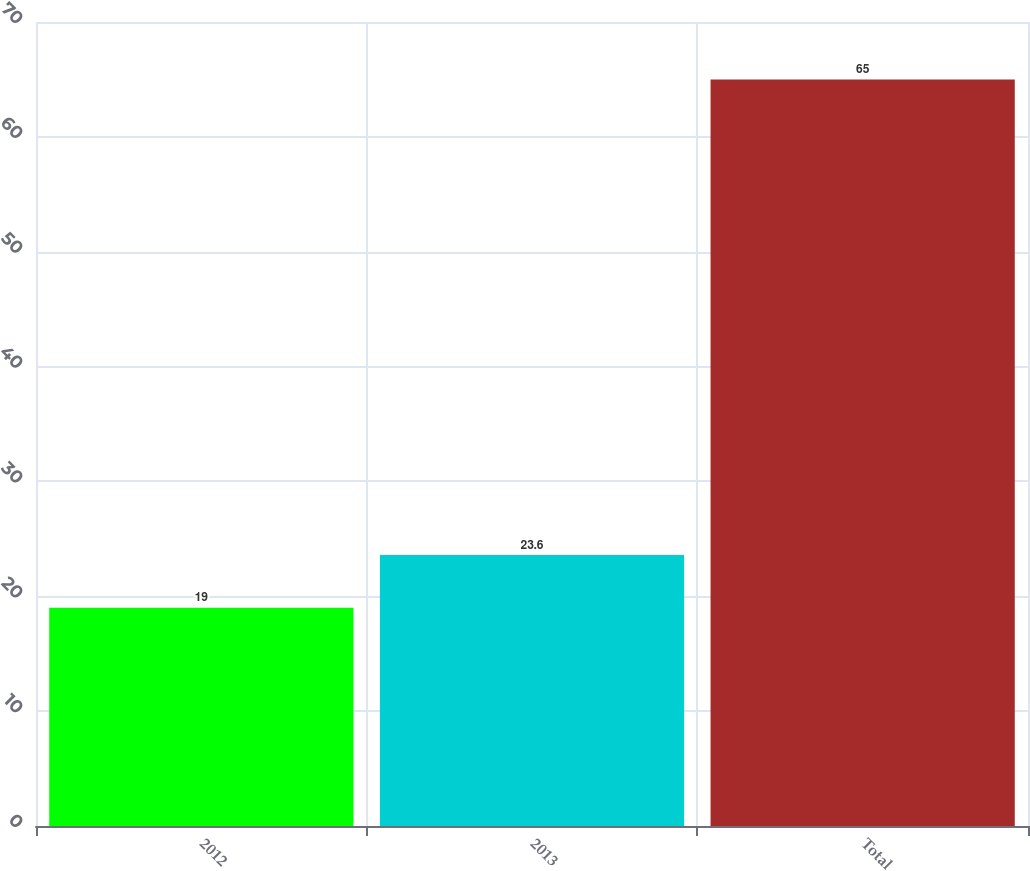<chart> <loc_0><loc_0><loc_500><loc_500><bar_chart><fcel>2012<fcel>2013<fcel>Total<nl><fcel>19<fcel>23.6<fcel>65<nl></chart> 